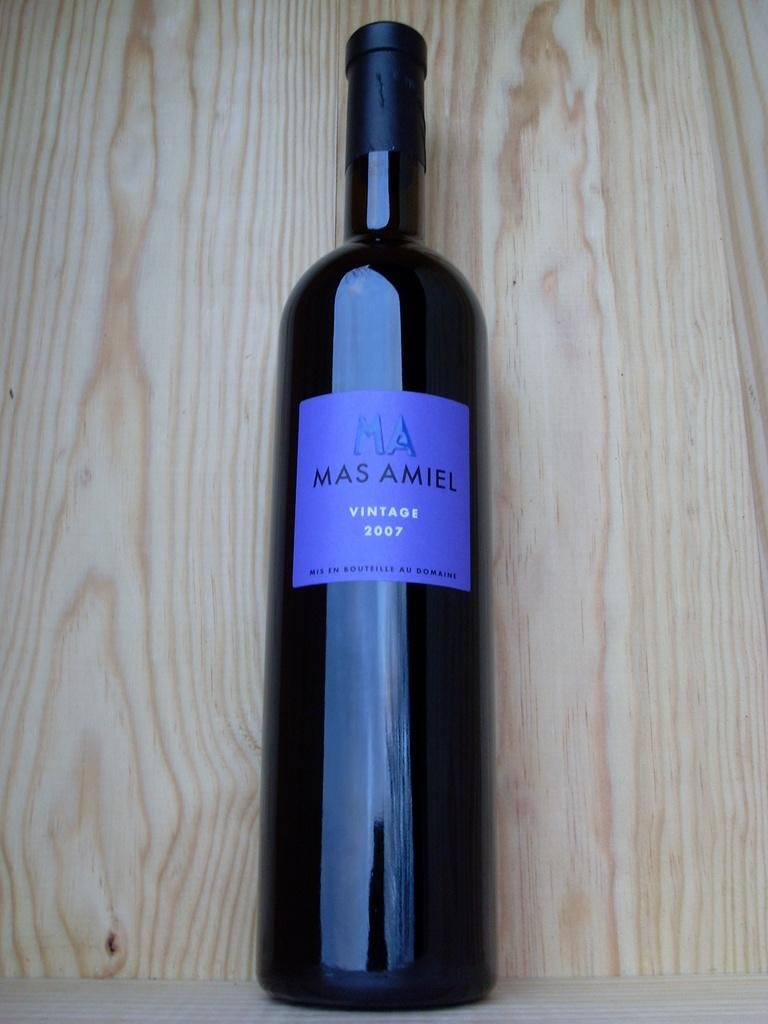Provide a one-sentence caption for the provided image. A vintage 2007 bottle of Mas Amiel is laying on a piece of wood. 